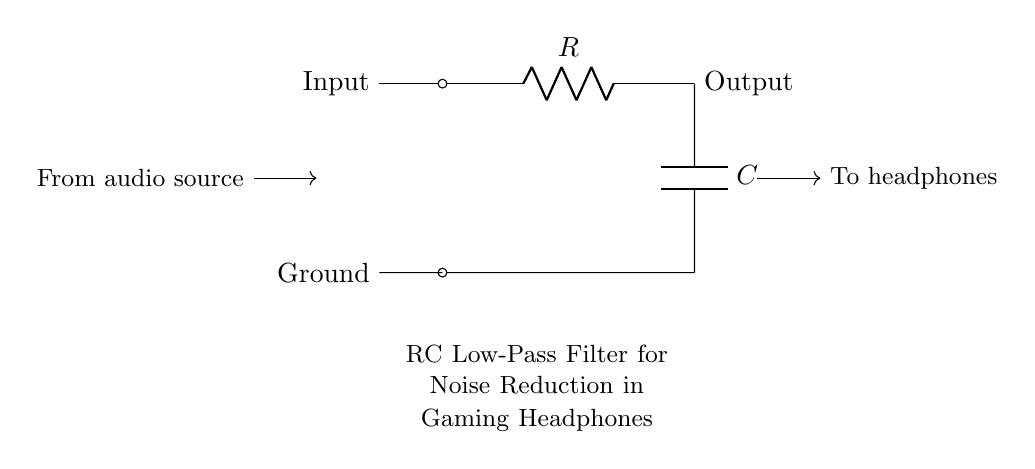What is the component connected to the output? The output connects to the capacitor in this RC filter. This point is where the filtered signal exits the circuit, representing the output of the noise reduction.
Answer: Capacitor What type of filter is represented by this circuit? The circuit diagram illustrates a low-pass filter. This is evident because it allows lower frequencies to pass through while attenuating higher frequencies, which is ideal for noise reduction in audio applications.
Answer: Low-pass filter What is the role of the resistor in this circuit? The resistor limits the current flowing through the circuit and determines the cutoff frequency of the filter, working in conjunction with the capacitor to filter noise from the audio signal.
Answer: Limit current What influences the cutoff frequency in this RC filter? The cutoff frequency in an RC filter is determined by the values of the resistor and capacitor. The formula for cutoff frequency is typically one divided by two times pi times the resistor value times the capacitor value, indicating that both components are crucial for setting this frequency.
Answer: Resistor and capacitor values How is the noise reduction achieved in this circuit? Noise reduction is achieved through the filtering action of the circuit. The RC combination filters out high-frequency noise components while allowing lower frequencies (the desired audio signals) to pass, thus cleaning the audio signal sent to the headphones.
Answer: Filtering action Where does the audio signal enter this circuit? The audio signal enters at the "Input" terminal on the left side of the circuit diagram. This is the point where the input audio from the source connects to the filter, starting the noise reduction process.
Answer: Input terminal 